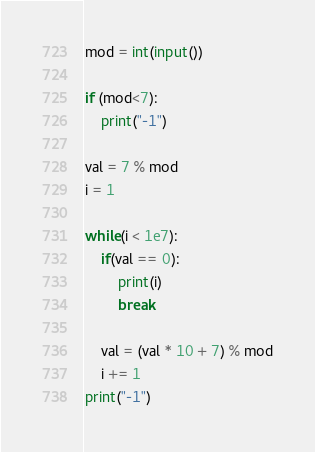Convert code to text. <code><loc_0><loc_0><loc_500><loc_500><_Python_>mod = int(input())

if (mod<7):
    print("-1")
    
val = 7 % mod
i = 1

while(i < 1e7):
    if(val == 0):
        print(i)
        break   

    val = (val * 10 + 7) % mod
    i += 1
print("-1")</code> 